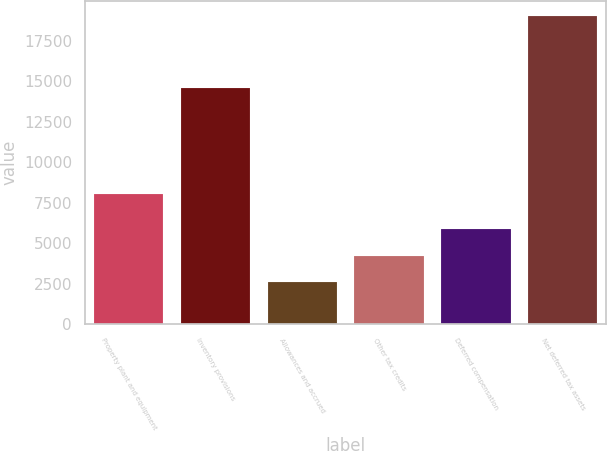<chart> <loc_0><loc_0><loc_500><loc_500><bar_chart><fcel>Property plant and equipment<fcel>Inventory provisions<fcel>Allowances and accrued<fcel>Other tax credits<fcel>Deferred compensation<fcel>Net deferred tax assets<nl><fcel>8031<fcel>14566<fcel>2590<fcel>4233.4<fcel>5891<fcel>19024<nl></chart> 